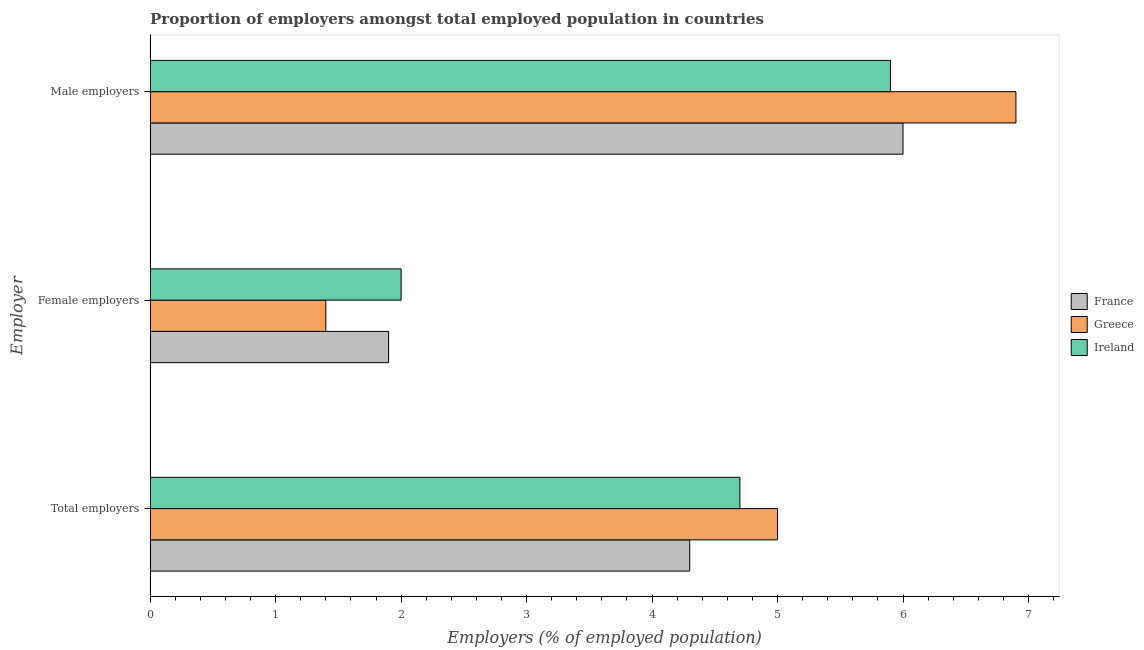Are the number of bars per tick equal to the number of legend labels?
Make the answer very short. Yes. Are the number of bars on each tick of the Y-axis equal?
Your answer should be compact. Yes. How many bars are there on the 1st tick from the top?
Make the answer very short. 3. How many bars are there on the 3rd tick from the bottom?
Ensure brevity in your answer.  3. What is the label of the 3rd group of bars from the top?
Your answer should be very brief. Total employers. What is the percentage of total employers in Ireland?
Make the answer very short. 4.7. Across all countries, what is the maximum percentage of male employers?
Your response must be concise. 6.9. Across all countries, what is the minimum percentage of female employers?
Your answer should be very brief. 1.4. In which country was the percentage of female employers maximum?
Provide a succinct answer. Ireland. What is the total percentage of male employers in the graph?
Provide a short and direct response. 18.8. What is the difference between the percentage of female employers in Greece and that in Ireland?
Offer a very short reply. -0.6. What is the difference between the percentage of male employers in Ireland and the percentage of total employers in Greece?
Your response must be concise. 0.9. What is the average percentage of male employers per country?
Ensure brevity in your answer.  6.27. What is the difference between the percentage of female employers and percentage of total employers in Ireland?
Your answer should be very brief. -2.7. In how many countries, is the percentage of female employers greater than 5.6 %?
Your response must be concise. 0. What is the ratio of the percentage of female employers in Ireland to that in Greece?
Make the answer very short. 1.43. What is the difference between the highest and the second highest percentage of male employers?
Give a very brief answer. 0.9. What is the difference between the highest and the lowest percentage of female employers?
Give a very brief answer. 0.6. What does the 1st bar from the top in Male employers represents?
Give a very brief answer. Ireland. What does the 1st bar from the bottom in Female employers represents?
Your response must be concise. France. How many bars are there?
Give a very brief answer. 9. How many countries are there in the graph?
Provide a succinct answer. 3. Does the graph contain any zero values?
Provide a short and direct response. No. How many legend labels are there?
Make the answer very short. 3. What is the title of the graph?
Your answer should be very brief. Proportion of employers amongst total employed population in countries. Does "Haiti" appear as one of the legend labels in the graph?
Offer a very short reply. No. What is the label or title of the X-axis?
Keep it short and to the point. Employers (% of employed population). What is the label or title of the Y-axis?
Provide a succinct answer. Employer. What is the Employers (% of employed population) in France in Total employers?
Offer a very short reply. 4.3. What is the Employers (% of employed population) in Ireland in Total employers?
Provide a succinct answer. 4.7. What is the Employers (% of employed population) in France in Female employers?
Offer a terse response. 1.9. What is the Employers (% of employed population) of Greece in Female employers?
Offer a terse response. 1.4. What is the Employers (% of employed population) of Ireland in Female employers?
Ensure brevity in your answer.  2. What is the Employers (% of employed population) of Greece in Male employers?
Offer a very short reply. 6.9. What is the Employers (% of employed population) of Ireland in Male employers?
Your answer should be compact. 5.9. Across all Employer, what is the maximum Employers (% of employed population) of France?
Your response must be concise. 6. Across all Employer, what is the maximum Employers (% of employed population) in Greece?
Your answer should be compact. 6.9. Across all Employer, what is the maximum Employers (% of employed population) in Ireland?
Give a very brief answer. 5.9. Across all Employer, what is the minimum Employers (% of employed population) in France?
Your answer should be very brief. 1.9. Across all Employer, what is the minimum Employers (% of employed population) of Greece?
Offer a terse response. 1.4. Across all Employer, what is the minimum Employers (% of employed population) of Ireland?
Ensure brevity in your answer.  2. What is the total Employers (% of employed population) of Ireland in the graph?
Your answer should be very brief. 12.6. What is the difference between the Employers (% of employed population) of France in Total employers and that in Female employers?
Provide a succinct answer. 2.4. What is the difference between the Employers (% of employed population) in Greece in Total employers and that in Female employers?
Provide a succinct answer. 3.6. What is the difference between the Employers (% of employed population) of France in Female employers and that in Male employers?
Offer a very short reply. -4.1. What is the difference between the Employers (% of employed population) in Ireland in Female employers and that in Male employers?
Give a very brief answer. -3.9. What is the difference between the Employers (% of employed population) of France in Total employers and the Employers (% of employed population) of Ireland in Female employers?
Provide a short and direct response. 2.3. What is the difference between the Employers (% of employed population) in Greece in Total employers and the Employers (% of employed population) in Ireland in Female employers?
Your response must be concise. 3. What is the difference between the Employers (% of employed population) in Greece in Total employers and the Employers (% of employed population) in Ireland in Male employers?
Give a very brief answer. -0.9. What is the difference between the Employers (% of employed population) in France in Female employers and the Employers (% of employed population) in Greece in Male employers?
Keep it short and to the point. -5. What is the difference between the Employers (% of employed population) of Greece in Female employers and the Employers (% of employed population) of Ireland in Male employers?
Your response must be concise. -4.5. What is the average Employers (% of employed population) in France per Employer?
Give a very brief answer. 4.07. What is the average Employers (% of employed population) of Greece per Employer?
Make the answer very short. 4.43. What is the average Employers (% of employed population) of Ireland per Employer?
Your answer should be very brief. 4.2. What is the difference between the Employers (% of employed population) in Greece and Employers (% of employed population) in Ireland in Total employers?
Your answer should be compact. 0.3. What is the difference between the Employers (% of employed population) in France and Employers (% of employed population) in Greece in Female employers?
Offer a terse response. 0.5. What is the difference between the Employers (% of employed population) of Greece and Employers (% of employed population) of Ireland in Female employers?
Offer a terse response. -0.6. What is the difference between the Employers (% of employed population) of France and Employers (% of employed population) of Greece in Male employers?
Offer a terse response. -0.9. What is the ratio of the Employers (% of employed population) of France in Total employers to that in Female employers?
Your answer should be very brief. 2.26. What is the ratio of the Employers (% of employed population) of Greece in Total employers to that in Female employers?
Give a very brief answer. 3.57. What is the ratio of the Employers (% of employed population) of Ireland in Total employers to that in Female employers?
Give a very brief answer. 2.35. What is the ratio of the Employers (% of employed population) of France in Total employers to that in Male employers?
Your answer should be compact. 0.72. What is the ratio of the Employers (% of employed population) in Greece in Total employers to that in Male employers?
Give a very brief answer. 0.72. What is the ratio of the Employers (% of employed population) of Ireland in Total employers to that in Male employers?
Offer a very short reply. 0.8. What is the ratio of the Employers (% of employed population) in France in Female employers to that in Male employers?
Provide a short and direct response. 0.32. What is the ratio of the Employers (% of employed population) in Greece in Female employers to that in Male employers?
Your answer should be compact. 0.2. What is the ratio of the Employers (% of employed population) in Ireland in Female employers to that in Male employers?
Your answer should be very brief. 0.34. What is the difference between the highest and the lowest Employers (% of employed population) of Greece?
Ensure brevity in your answer.  5.5. 